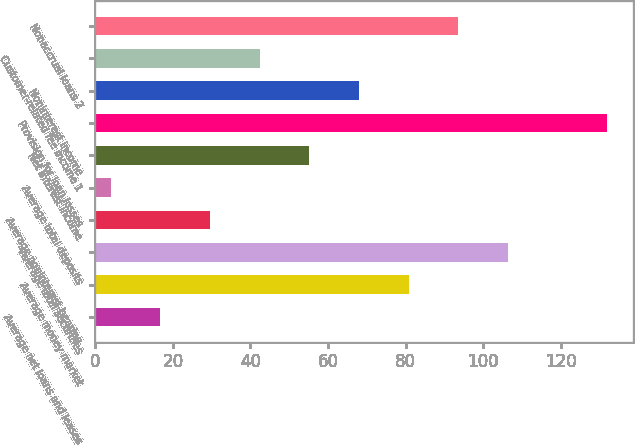Convert chart to OTSL. <chart><loc_0><loc_0><loc_500><loc_500><bar_chart><fcel>Average net loans and leases<fcel>Average money market<fcel>Average total securities<fcel>Average noninterest-bearing<fcel>Average total deposits<fcel>Net interest income<fcel>Provision for loan losses<fcel>Noninterest income<fcel>Customer-related fee income 1<fcel>Nonaccrual loans 2<nl><fcel>16.8<fcel>80.8<fcel>106.4<fcel>29.6<fcel>4<fcel>55.2<fcel>132<fcel>68<fcel>42.4<fcel>93.6<nl></chart> 